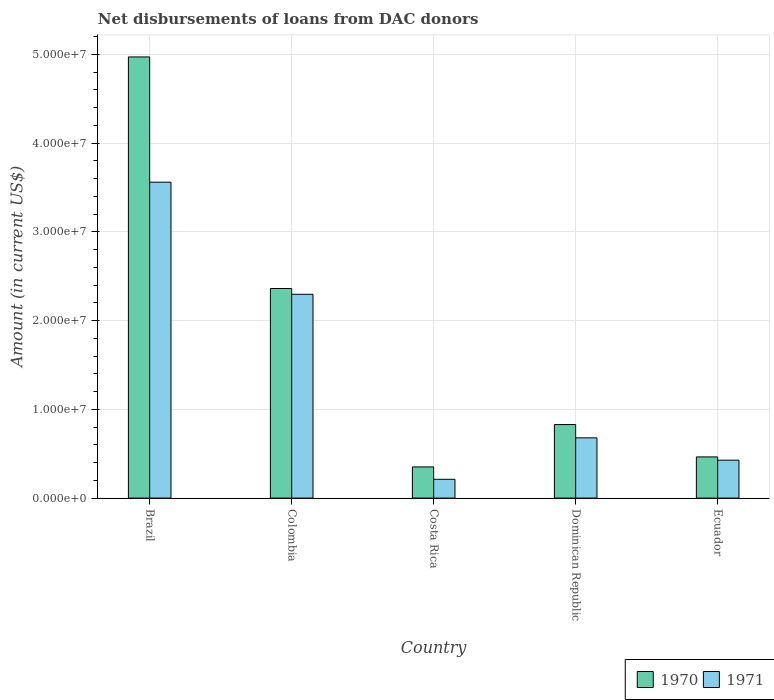How many different coloured bars are there?
Make the answer very short. 2. How many groups of bars are there?
Ensure brevity in your answer.  5. Are the number of bars on each tick of the X-axis equal?
Your answer should be compact. Yes. How many bars are there on the 1st tick from the right?
Offer a terse response. 2. What is the label of the 5th group of bars from the left?
Your answer should be compact. Ecuador. What is the amount of loans disbursed in 1970 in Costa Rica?
Offer a terse response. 3.51e+06. Across all countries, what is the maximum amount of loans disbursed in 1970?
Provide a short and direct response. 4.97e+07. Across all countries, what is the minimum amount of loans disbursed in 1970?
Offer a terse response. 3.51e+06. In which country was the amount of loans disbursed in 1970 maximum?
Make the answer very short. Brazil. In which country was the amount of loans disbursed in 1970 minimum?
Provide a succinct answer. Costa Rica. What is the total amount of loans disbursed in 1970 in the graph?
Your answer should be compact. 8.98e+07. What is the difference between the amount of loans disbursed in 1971 in Dominican Republic and that in Ecuador?
Provide a succinct answer. 2.52e+06. What is the difference between the amount of loans disbursed in 1971 in Ecuador and the amount of loans disbursed in 1970 in Colombia?
Keep it short and to the point. -1.93e+07. What is the average amount of loans disbursed in 1970 per country?
Ensure brevity in your answer.  1.80e+07. What is the difference between the amount of loans disbursed of/in 1970 and amount of loans disbursed of/in 1971 in Brazil?
Provide a succinct answer. 1.41e+07. In how many countries, is the amount of loans disbursed in 1970 greater than 20000000 US$?
Your answer should be compact. 2. What is the ratio of the amount of loans disbursed in 1971 in Colombia to that in Dominican Republic?
Provide a succinct answer. 3.38. Is the amount of loans disbursed in 1970 in Costa Rica less than that in Ecuador?
Keep it short and to the point. Yes. What is the difference between the highest and the second highest amount of loans disbursed in 1971?
Your answer should be very brief. 1.26e+07. What is the difference between the highest and the lowest amount of loans disbursed in 1971?
Give a very brief answer. 3.35e+07. In how many countries, is the amount of loans disbursed in 1970 greater than the average amount of loans disbursed in 1970 taken over all countries?
Make the answer very short. 2. What does the 1st bar from the right in Brazil represents?
Your response must be concise. 1971. What is the difference between two consecutive major ticks on the Y-axis?
Give a very brief answer. 1.00e+07. Are the values on the major ticks of Y-axis written in scientific E-notation?
Your answer should be very brief. Yes. Does the graph contain grids?
Keep it short and to the point. Yes. Where does the legend appear in the graph?
Provide a short and direct response. Bottom right. What is the title of the graph?
Provide a short and direct response. Net disbursements of loans from DAC donors. What is the label or title of the X-axis?
Keep it short and to the point. Country. What is the label or title of the Y-axis?
Keep it short and to the point. Amount (in current US$). What is the Amount (in current US$) of 1970 in Brazil?
Offer a terse response. 4.97e+07. What is the Amount (in current US$) in 1971 in Brazil?
Ensure brevity in your answer.  3.56e+07. What is the Amount (in current US$) of 1970 in Colombia?
Provide a short and direct response. 2.36e+07. What is the Amount (in current US$) in 1971 in Colombia?
Make the answer very short. 2.30e+07. What is the Amount (in current US$) of 1970 in Costa Rica?
Your answer should be compact. 3.51e+06. What is the Amount (in current US$) of 1971 in Costa Rica?
Provide a succinct answer. 2.12e+06. What is the Amount (in current US$) of 1970 in Dominican Republic?
Make the answer very short. 8.29e+06. What is the Amount (in current US$) in 1971 in Dominican Republic?
Provide a succinct answer. 6.79e+06. What is the Amount (in current US$) in 1970 in Ecuador?
Offer a very short reply. 4.64e+06. What is the Amount (in current US$) in 1971 in Ecuador?
Offer a terse response. 4.27e+06. Across all countries, what is the maximum Amount (in current US$) in 1970?
Provide a short and direct response. 4.97e+07. Across all countries, what is the maximum Amount (in current US$) of 1971?
Your answer should be compact. 3.56e+07. Across all countries, what is the minimum Amount (in current US$) of 1970?
Your response must be concise. 3.51e+06. Across all countries, what is the minimum Amount (in current US$) of 1971?
Keep it short and to the point. 2.12e+06. What is the total Amount (in current US$) of 1970 in the graph?
Ensure brevity in your answer.  8.98e+07. What is the total Amount (in current US$) of 1971 in the graph?
Ensure brevity in your answer.  7.17e+07. What is the difference between the Amount (in current US$) of 1970 in Brazil and that in Colombia?
Ensure brevity in your answer.  2.61e+07. What is the difference between the Amount (in current US$) of 1971 in Brazil and that in Colombia?
Offer a very short reply. 1.26e+07. What is the difference between the Amount (in current US$) in 1970 in Brazil and that in Costa Rica?
Ensure brevity in your answer.  4.62e+07. What is the difference between the Amount (in current US$) in 1971 in Brazil and that in Costa Rica?
Offer a terse response. 3.35e+07. What is the difference between the Amount (in current US$) in 1970 in Brazil and that in Dominican Republic?
Your answer should be compact. 4.14e+07. What is the difference between the Amount (in current US$) of 1971 in Brazil and that in Dominican Republic?
Your answer should be compact. 2.88e+07. What is the difference between the Amount (in current US$) of 1970 in Brazil and that in Ecuador?
Your answer should be very brief. 4.51e+07. What is the difference between the Amount (in current US$) of 1971 in Brazil and that in Ecuador?
Offer a terse response. 3.13e+07. What is the difference between the Amount (in current US$) of 1970 in Colombia and that in Costa Rica?
Your answer should be compact. 2.01e+07. What is the difference between the Amount (in current US$) of 1971 in Colombia and that in Costa Rica?
Ensure brevity in your answer.  2.08e+07. What is the difference between the Amount (in current US$) of 1970 in Colombia and that in Dominican Republic?
Keep it short and to the point. 1.53e+07. What is the difference between the Amount (in current US$) in 1971 in Colombia and that in Dominican Republic?
Your response must be concise. 1.62e+07. What is the difference between the Amount (in current US$) of 1970 in Colombia and that in Ecuador?
Your response must be concise. 1.90e+07. What is the difference between the Amount (in current US$) of 1971 in Colombia and that in Ecuador?
Provide a short and direct response. 1.87e+07. What is the difference between the Amount (in current US$) of 1970 in Costa Rica and that in Dominican Republic?
Provide a succinct answer. -4.77e+06. What is the difference between the Amount (in current US$) of 1971 in Costa Rica and that in Dominican Republic?
Make the answer very short. -4.67e+06. What is the difference between the Amount (in current US$) of 1970 in Costa Rica and that in Ecuador?
Provide a short and direct response. -1.13e+06. What is the difference between the Amount (in current US$) in 1971 in Costa Rica and that in Ecuador?
Your answer should be very brief. -2.16e+06. What is the difference between the Amount (in current US$) of 1970 in Dominican Republic and that in Ecuador?
Your answer should be compact. 3.65e+06. What is the difference between the Amount (in current US$) in 1971 in Dominican Republic and that in Ecuador?
Give a very brief answer. 2.52e+06. What is the difference between the Amount (in current US$) in 1970 in Brazil and the Amount (in current US$) in 1971 in Colombia?
Ensure brevity in your answer.  2.67e+07. What is the difference between the Amount (in current US$) of 1970 in Brazil and the Amount (in current US$) of 1971 in Costa Rica?
Offer a very short reply. 4.76e+07. What is the difference between the Amount (in current US$) in 1970 in Brazil and the Amount (in current US$) in 1971 in Dominican Republic?
Your response must be concise. 4.29e+07. What is the difference between the Amount (in current US$) in 1970 in Brazil and the Amount (in current US$) in 1971 in Ecuador?
Make the answer very short. 4.54e+07. What is the difference between the Amount (in current US$) of 1970 in Colombia and the Amount (in current US$) of 1971 in Costa Rica?
Provide a succinct answer. 2.15e+07. What is the difference between the Amount (in current US$) in 1970 in Colombia and the Amount (in current US$) in 1971 in Dominican Republic?
Provide a succinct answer. 1.68e+07. What is the difference between the Amount (in current US$) of 1970 in Colombia and the Amount (in current US$) of 1971 in Ecuador?
Your answer should be compact. 1.93e+07. What is the difference between the Amount (in current US$) of 1970 in Costa Rica and the Amount (in current US$) of 1971 in Dominican Republic?
Your answer should be compact. -3.28e+06. What is the difference between the Amount (in current US$) in 1970 in Costa Rica and the Amount (in current US$) in 1971 in Ecuador?
Provide a short and direct response. -7.58e+05. What is the difference between the Amount (in current US$) of 1970 in Dominican Republic and the Amount (in current US$) of 1971 in Ecuador?
Give a very brief answer. 4.02e+06. What is the average Amount (in current US$) of 1970 per country?
Provide a succinct answer. 1.80e+07. What is the average Amount (in current US$) in 1971 per country?
Provide a succinct answer. 1.43e+07. What is the difference between the Amount (in current US$) of 1970 and Amount (in current US$) of 1971 in Brazil?
Give a very brief answer. 1.41e+07. What is the difference between the Amount (in current US$) of 1970 and Amount (in current US$) of 1971 in Colombia?
Keep it short and to the point. 6.52e+05. What is the difference between the Amount (in current US$) of 1970 and Amount (in current US$) of 1971 in Costa Rica?
Your answer should be compact. 1.40e+06. What is the difference between the Amount (in current US$) of 1970 and Amount (in current US$) of 1971 in Dominican Republic?
Provide a succinct answer. 1.50e+06. What is the difference between the Amount (in current US$) in 1970 and Amount (in current US$) in 1971 in Ecuador?
Your answer should be compact. 3.68e+05. What is the ratio of the Amount (in current US$) in 1970 in Brazil to that in Colombia?
Your answer should be compact. 2.1. What is the ratio of the Amount (in current US$) of 1971 in Brazil to that in Colombia?
Your response must be concise. 1.55. What is the ratio of the Amount (in current US$) of 1970 in Brazil to that in Costa Rica?
Your answer should be compact. 14.15. What is the ratio of the Amount (in current US$) of 1971 in Brazil to that in Costa Rica?
Offer a very short reply. 16.82. What is the ratio of the Amount (in current US$) of 1970 in Brazil to that in Dominican Republic?
Give a very brief answer. 6. What is the ratio of the Amount (in current US$) of 1971 in Brazil to that in Dominican Republic?
Give a very brief answer. 5.24. What is the ratio of the Amount (in current US$) in 1970 in Brazil to that in Ecuador?
Ensure brevity in your answer.  10.72. What is the ratio of the Amount (in current US$) in 1971 in Brazil to that in Ecuador?
Make the answer very short. 8.33. What is the ratio of the Amount (in current US$) in 1970 in Colombia to that in Costa Rica?
Make the answer very short. 6.72. What is the ratio of the Amount (in current US$) of 1971 in Colombia to that in Costa Rica?
Your answer should be compact. 10.85. What is the ratio of the Amount (in current US$) of 1970 in Colombia to that in Dominican Republic?
Give a very brief answer. 2.85. What is the ratio of the Amount (in current US$) of 1971 in Colombia to that in Dominican Republic?
Your answer should be compact. 3.38. What is the ratio of the Amount (in current US$) of 1970 in Colombia to that in Ecuador?
Your answer should be compact. 5.09. What is the ratio of the Amount (in current US$) of 1971 in Colombia to that in Ecuador?
Ensure brevity in your answer.  5.38. What is the ratio of the Amount (in current US$) of 1970 in Costa Rica to that in Dominican Republic?
Your answer should be very brief. 0.42. What is the ratio of the Amount (in current US$) of 1971 in Costa Rica to that in Dominican Republic?
Offer a terse response. 0.31. What is the ratio of the Amount (in current US$) of 1970 in Costa Rica to that in Ecuador?
Make the answer very short. 0.76. What is the ratio of the Amount (in current US$) of 1971 in Costa Rica to that in Ecuador?
Provide a succinct answer. 0.5. What is the ratio of the Amount (in current US$) of 1970 in Dominican Republic to that in Ecuador?
Make the answer very short. 1.79. What is the ratio of the Amount (in current US$) in 1971 in Dominican Republic to that in Ecuador?
Your answer should be compact. 1.59. What is the difference between the highest and the second highest Amount (in current US$) in 1970?
Your response must be concise. 2.61e+07. What is the difference between the highest and the second highest Amount (in current US$) in 1971?
Keep it short and to the point. 1.26e+07. What is the difference between the highest and the lowest Amount (in current US$) in 1970?
Your response must be concise. 4.62e+07. What is the difference between the highest and the lowest Amount (in current US$) of 1971?
Your answer should be compact. 3.35e+07. 